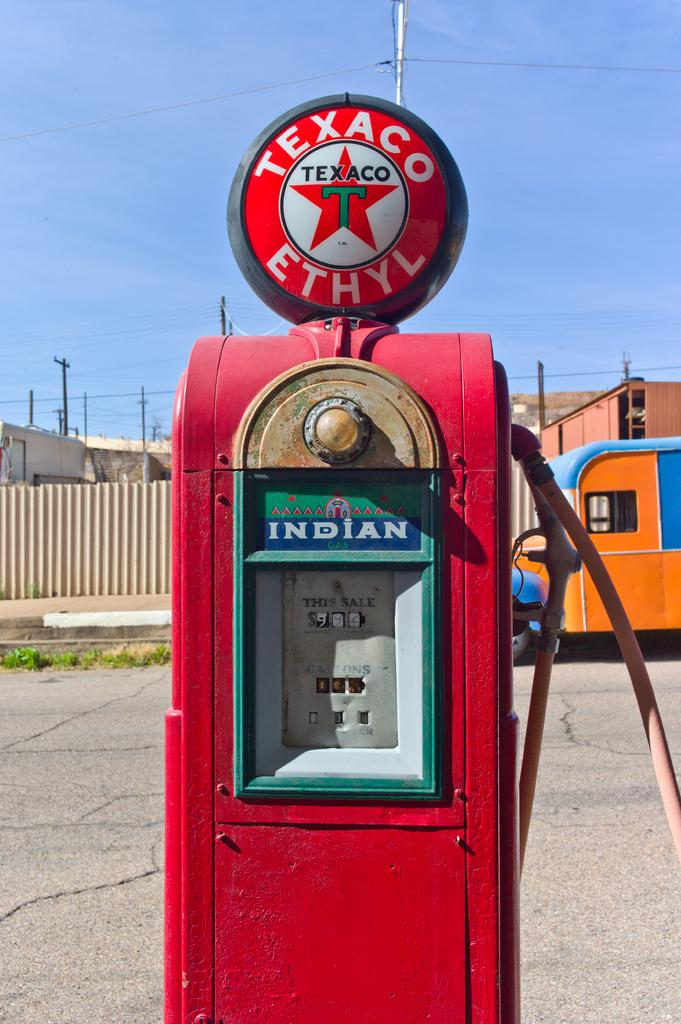What can be seen in the sky in the image? The sky is visible in the image. What structures are present in the image? There are electric poles in the image. What is connected to the electric poles? Electric cables are present in the image. What type of vehicles can be seen on the road in the image? Motor vehicles are on the road in the image. What type of vegetation is visible in the image? Grass is visible in the image. What type of machine is present in the image? There is a machine in the image. What type of nose can be seen on the machine in the image? There is no nose present on the machine in the image. What type of mine is visible in the image? There is no mine present in the image. 